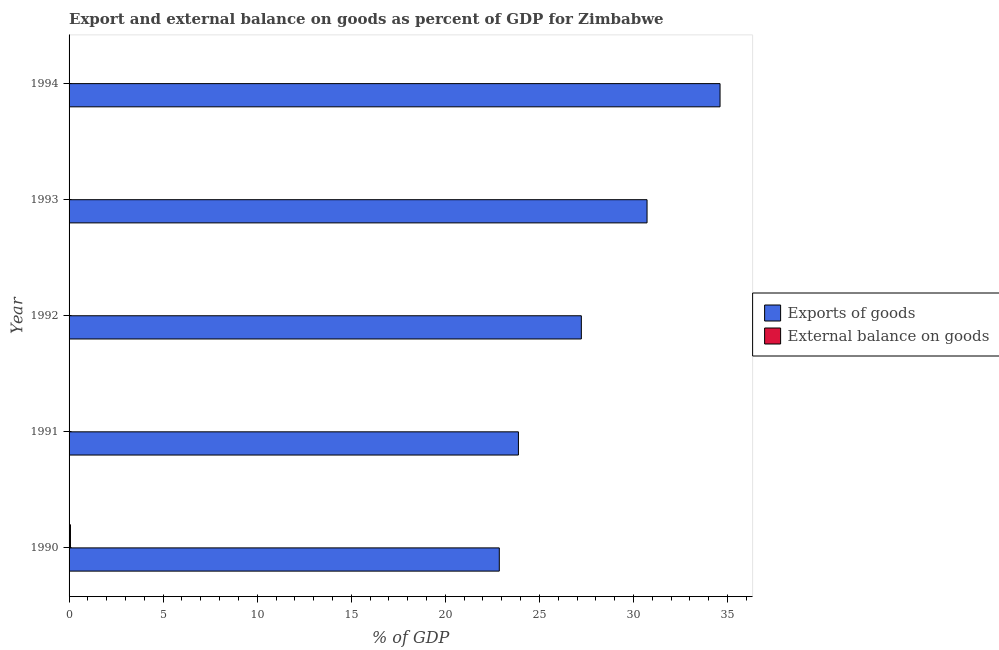How many different coloured bars are there?
Your response must be concise. 2. Are the number of bars on each tick of the Y-axis equal?
Make the answer very short. No. How many bars are there on the 2nd tick from the top?
Ensure brevity in your answer.  1. How many bars are there on the 3rd tick from the bottom?
Your response must be concise. 1. What is the label of the 4th group of bars from the top?
Your response must be concise. 1991. In how many cases, is the number of bars for a given year not equal to the number of legend labels?
Make the answer very short. 4. Across all years, what is the maximum export of goods as percentage of gdp?
Provide a succinct answer. 34.6. In which year was the external balance on goods as percentage of gdp maximum?
Your answer should be compact. 1990. What is the total export of goods as percentage of gdp in the graph?
Provide a short and direct response. 139.3. What is the difference between the export of goods as percentage of gdp in 1990 and that in 1991?
Your answer should be very brief. -1.02. What is the difference between the external balance on goods as percentage of gdp in 1993 and the export of goods as percentage of gdp in 1990?
Provide a short and direct response. -22.87. What is the average external balance on goods as percentage of gdp per year?
Make the answer very short. 0.01. In the year 1990, what is the difference between the external balance on goods as percentage of gdp and export of goods as percentage of gdp?
Offer a very short reply. -22.79. In how many years, is the external balance on goods as percentage of gdp greater than 10 %?
Provide a short and direct response. 0. What is the ratio of the export of goods as percentage of gdp in 1992 to that in 1993?
Make the answer very short. 0.89. Is the export of goods as percentage of gdp in 1991 less than that in 1994?
Give a very brief answer. Yes. What is the difference between the highest and the second highest export of goods as percentage of gdp?
Make the answer very short. 3.88. What is the difference between the highest and the lowest external balance on goods as percentage of gdp?
Ensure brevity in your answer.  0.07. How many bars are there?
Offer a terse response. 6. Are the values on the major ticks of X-axis written in scientific E-notation?
Provide a short and direct response. No. Does the graph contain any zero values?
Your response must be concise. Yes. Does the graph contain grids?
Provide a short and direct response. No. What is the title of the graph?
Ensure brevity in your answer.  Export and external balance on goods as percent of GDP for Zimbabwe. What is the label or title of the X-axis?
Offer a terse response. % of GDP. What is the label or title of the Y-axis?
Give a very brief answer. Year. What is the % of GDP in Exports of goods in 1990?
Your answer should be very brief. 22.87. What is the % of GDP of External balance on goods in 1990?
Your answer should be compact. 0.07. What is the % of GDP in Exports of goods in 1991?
Offer a terse response. 23.88. What is the % of GDP of Exports of goods in 1992?
Make the answer very short. 27.23. What is the % of GDP of External balance on goods in 1992?
Give a very brief answer. 0. What is the % of GDP in Exports of goods in 1993?
Offer a very short reply. 30.72. What is the % of GDP in External balance on goods in 1993?
Your answer should be very brief. 0. What is the % of GDP of Exports of goods in 1994?
Provide a succinct answer. 34.6. What is the % of GDP of External balance on goods in 1994?
Provide a short and direct response. 0. Across all years, what is the maximum % of GDP of Exports of goods?
Give a very brief answer. 34.6. Across all years, what is the maximum % of GDP of External balance on goods?
Keep it short and to the point. 0.07. Across all years, what is the minimum % of GDP in Exports of goods?
Offer a terse response. 22.87. What is the total % of GDP in Exports of goods in the graph?
Your answer should be very brief. 139.3. What is the total % of GDP of External balance on goods in the graph?
Offer a very short reply. 0.07. What is the difference between the % of GDP of Exports of goods in 1990 and that in 1991?
Keep it short and to the point. -1.02. What is the difference between the % of GDP in Exports of goods in 1990 and that in 1992?
Offer a very short reply. -4.36. What is the difference between the % of GDP of Exports of goods in 1990 and that in 1993?
Provide a succinct answer. -7.85. What is the difference between the % of GDP in Exports of goods in 1990 and that in 1994?
Provide a short and direct response. -11.73. What is the difference between the % of GDP in Exports of goods in 1991 and that in 1992?
Offer a terse response. -3.34. What is the difference between the % of GDP of Exports of goods in 1991 and that in 1993?
Offer a terse response. -6.84. What is the difference between the % of GDP of Exports of goods in 1991 and that in 1994?
Provide a short and direct response. -10.72. What is the difference between the % of GDP in Exports of goods in 1992 and that in 1993?
Offer a very short reply. -3.49. What is the difference between the % of GDP in Exports of goods in 1992 and that in 1994?
Your response must be concise. -7.37. What is the difference between the % of GDP in Exports of goods in 1993 and that in 1994?
Provide a succinct answer. -3.88. What is the average % of GDP in Exports of goods per year?
Keep it short and to the point. 27.86. What is the average % of GDP in External balance on goods per year?
Provide a succinct answer. 0.01. In the year 1990, what is the difference between the % of GDP of Exports of goods and % of GDP of External balance on goods?
Provide a short and direct response. 22.79. What is the ratio of the % of GDP in Exports of goods in 1990 to that in 1991?
Offer a very short reply. 0.96. What is the ratio of the % of GDP in Exports of goods in 1990 to that in 1992?
Offer a very short reply. 0.84. What is the ratio of the % of GDP of Exports of goods in 1990 to that in 1993?
Your answer should be very brief. 0.74. What is the ratio of the % of GDP of Exports of goods in 1990 to that in 1994?
Your response must be concise. 0.66. What is the ratio of the % of GDP of Exports of goods in 1991 to that in 1992?
Offer a very short reply. 0.88. What is the ratio of the % of GDP in Exports of goods in 1991 to that in 1993?
Your answer should be compact. 0.78. What is the ratio of the % of GDP in Exports of goods in 1991 to that in 1994?
Offer a very short reply. 0.69. What is the ratio of the % of GDP in Exports of goods in 1992 to that in 1993?
Ensure brevity in your answer.  0.89. What is the ratio of the % of GDP of Exports of goods in 1992 to that in 1994?
Provide a succinct answer. 0.79. What is the ratio of the % of GDP of Exports of goods in 1993 to that in 1994?
Your answer should be compact. 0.89. What is the difference between the highest and the second highest % of GDP in Exports of goods?
Offer a terse response. 3.88. What is the difference between the highest and the lowest % of GDP of Exports of goods?
Ensure brevity in your answer.  11.73. What is the difference between the highest and the lowest % of GDP in External balance on goods?
Ensure brevity in your answer.  0.07. 